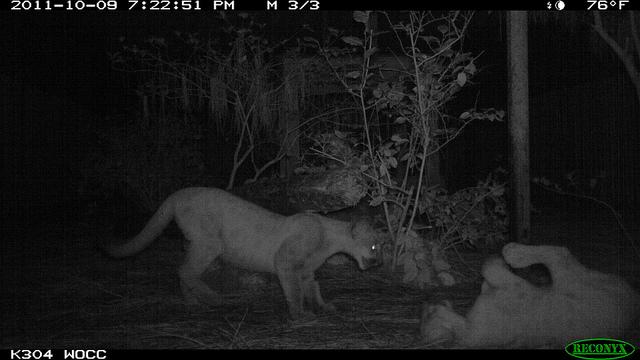What animal is this?
Answer briefly. Lion. How many pictures are there?
Give a very brief answer. 1. What time is it?
Be succinct. Night. What year were the animals photographed?
Short answer required. 2011. Is the sun out?
Answer briefly. No. Are the sheep laying down?
Give a very brief answer. No. How many real animals can you see?
Concise answer only. 2. Are these animals domesticated?
Give a very brief answer. No. Why are the eyes of the animal standing glowing in the dark?
Be succinct. Lion. What color is the sky?
Be succinct. Black. 